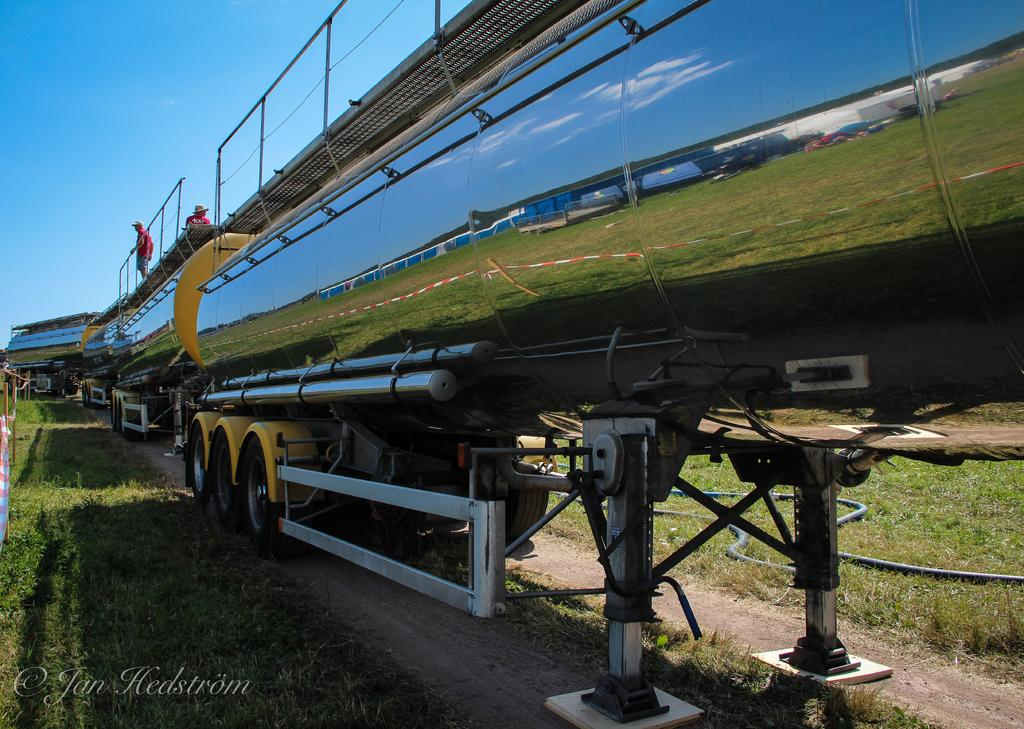What type of motor vehicle is in the image? The specific type of motor vehicle is not mentioned, but there is a motor vehicle present in the image. Who or what else can be seen in the image? There are persons in the image. What can be seen beneath the motor vehicle and persons? The ground is visible in the image. What can be seen above the motor vehicle and persons? The sky is visible in the image. Where is the throne located in the image? There is no throne present in the image. What type of cap is the person wearing in the image? The provided facts do not mention any caps or headwear, so it cannot be determined from the image. 